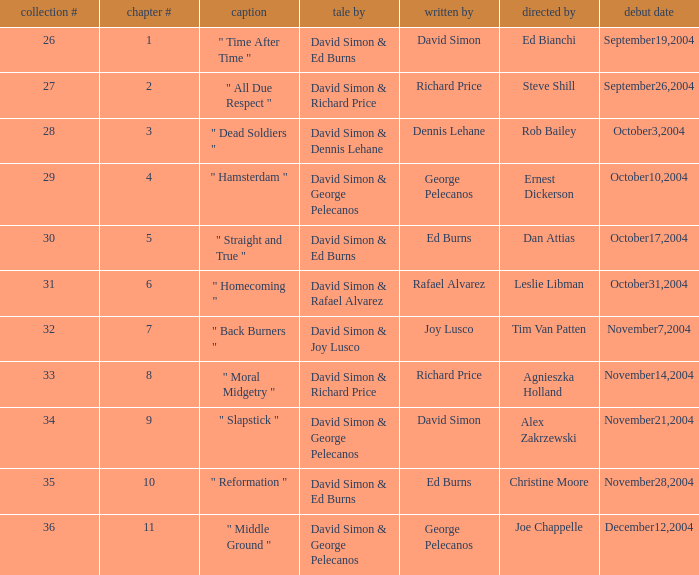Who is the teleplay by when the director is Rob Bailey? Dennis Lehane. 